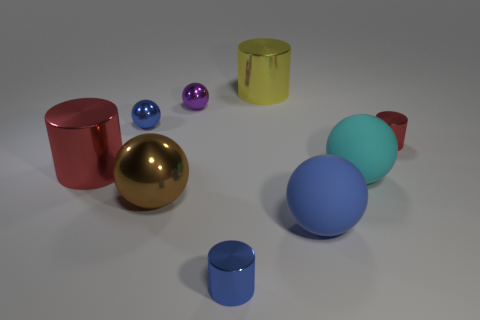What is the size of the cyan thing that is the same shape as the tiny purple shiny object?
Ensure brevity in your answer.  Large. Are the big brown thing behind the blue rubber object and the large cyan sphere made of the same material?
Make the answer very short. No. Does the brown metallic thing have the same shape as the large red thing?
Make the answer very short. No. What number of things are either cylinders that are behind the cyan object or tiny purple rubber cubes?
Give a very brief answer. 3. The blue sphere that is made of the same material as the cyan ball is what size?
Ensure brevity in your answer.  Large. What number of large things are purple metal spheres or blue metal cylinders?
Ensure brevity in your answer.  0. Is there another brown object made of the same material as the large brown object?
Offer a very short reply. No. What is the material of the tiny cylinder that is behind the blue matte object?
Your response must be concise. Metal. There is a big cylinder that is in front of the big yellow shiny cylinder; is it the same color as the large sphere that is on the left side of the yellow metallic cylinder?
Offer a very short reply. No. There is another rubber sphere that is the same size as the cyan rubber ball; what color is it?
Ensure brevity in your answer.  Blue. 